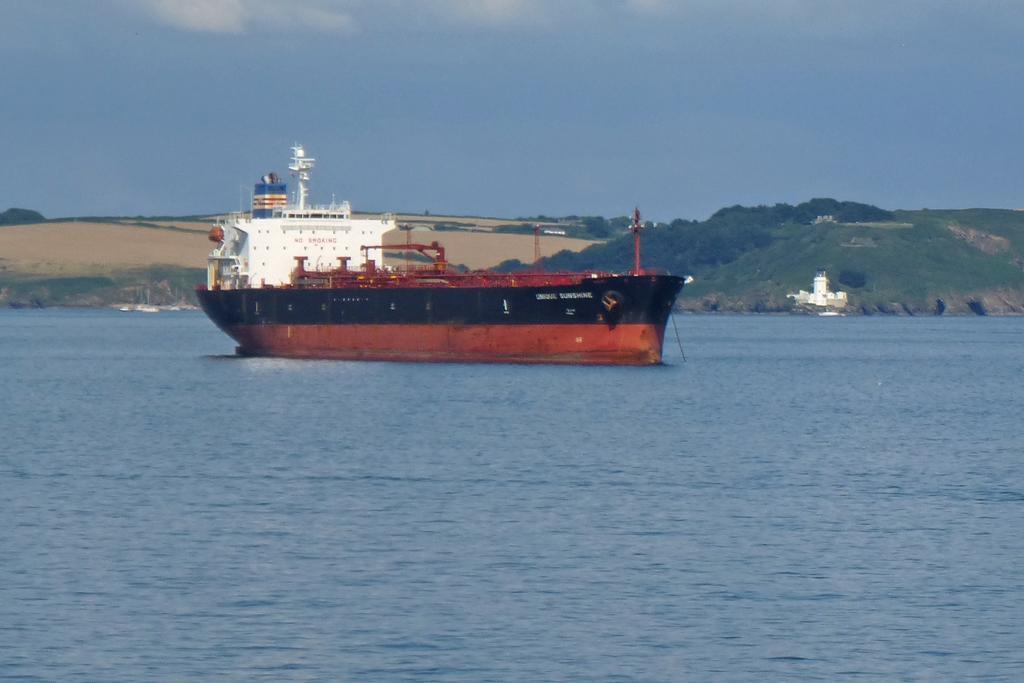Describe this image in one or two sentences. In this image we can see ship on the water. In the background we can see hills, buildings and sky with clouds. 